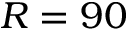<formula> <loc_0><loc_0><loc_500><loc_500>R = 9 0</formula> 